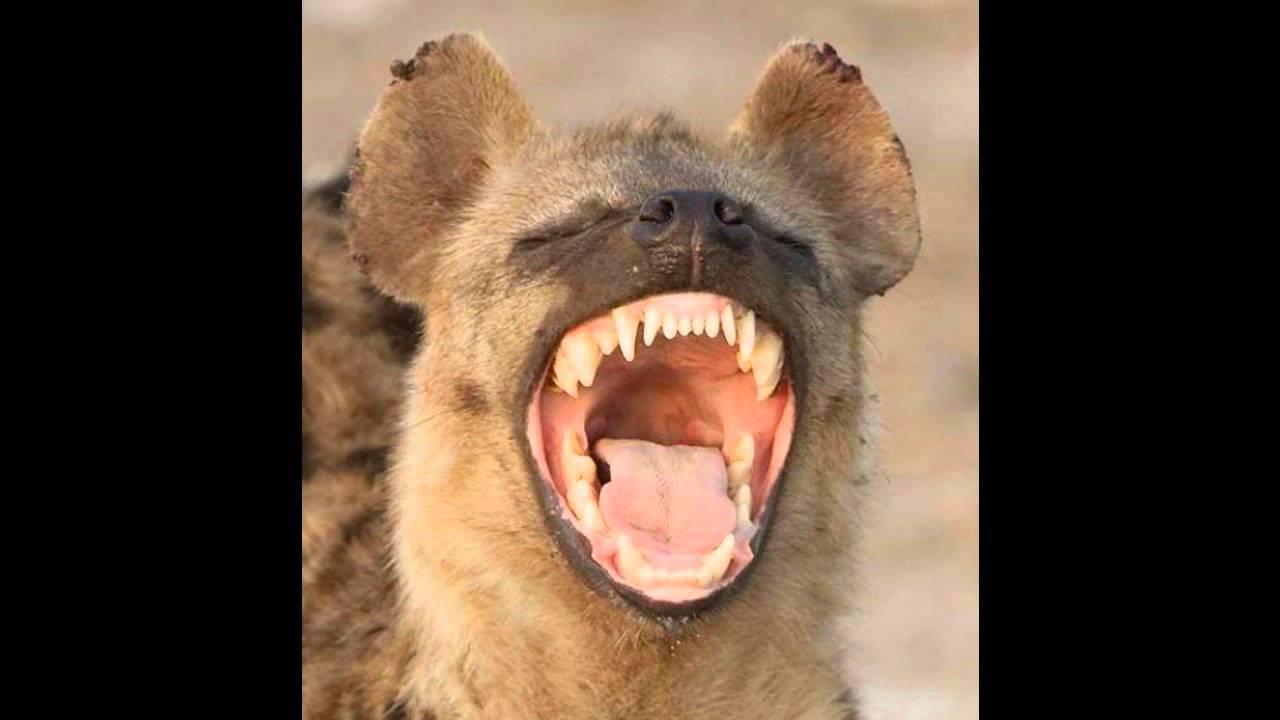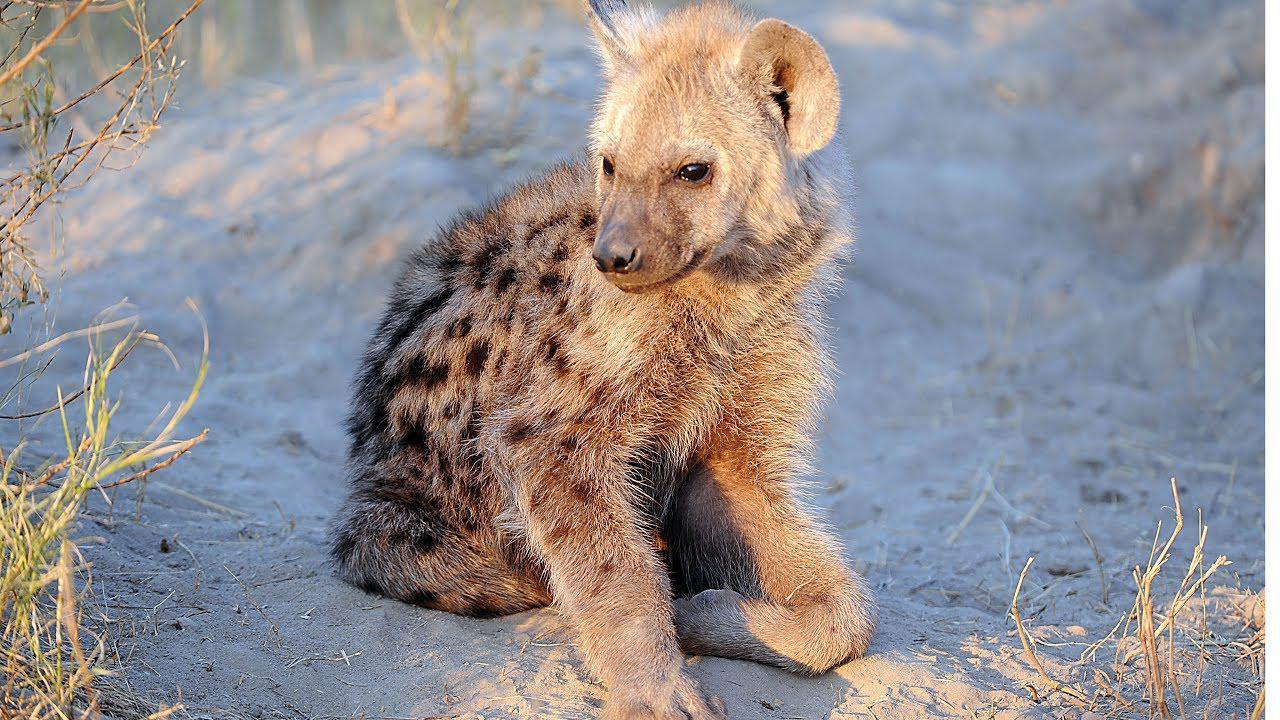The first image is the image on the left, the second image is the image on the right. Given the left and right images, does the statement "Exactly one hyena is showing his teeth and exactly one isn't." hold true? Answer yes or no. Yes. The first image is the image on the left, the second image is the image on the right. Assess this claim about the two images: "There is at least one pup present.". Correct or not? Answer yes or no. Yes. 